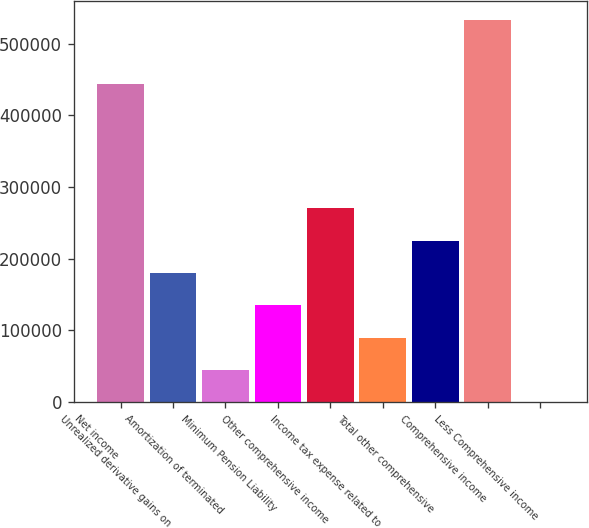<chart> <loc_0><loc_0><loc_500><loc_500><bar_chart><fcel>Net income<fcel>Unrealized derivative gains on<fcel>Amortization of terminated<fcel>Minimum Pension Liability<fcel>Other comprehensive income<fcel>Income tax expense related to<fcel>Total other comprehensive<fcel>Comprehensive income<fcel>Less Comprehensive income<nl><fcel>443446<fcel>180187<fcel>45046.9<fcel>135140<fcel>270280<fcel>90093.6<fcel>225234<fcel>533539<fcel>0.22<nl></chart> 